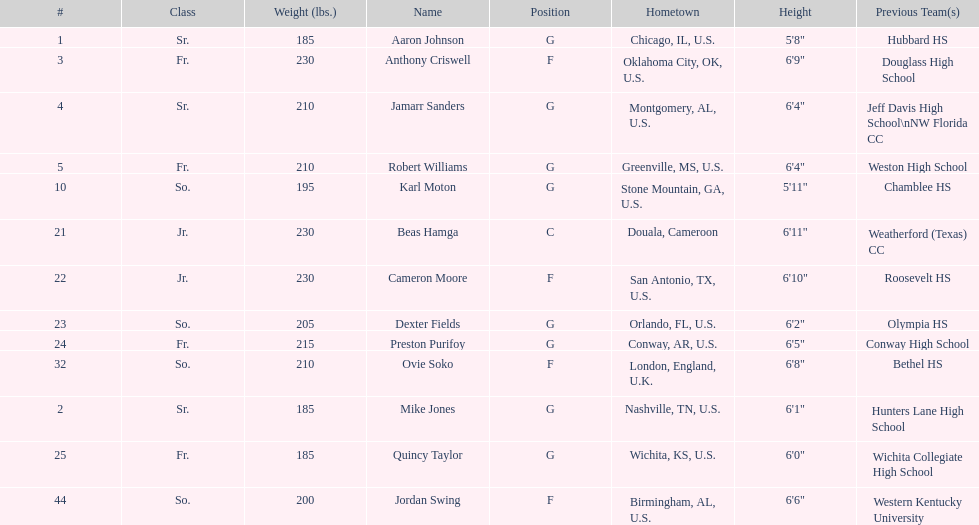Who is the tallest player on the team? Beas Hamga. 